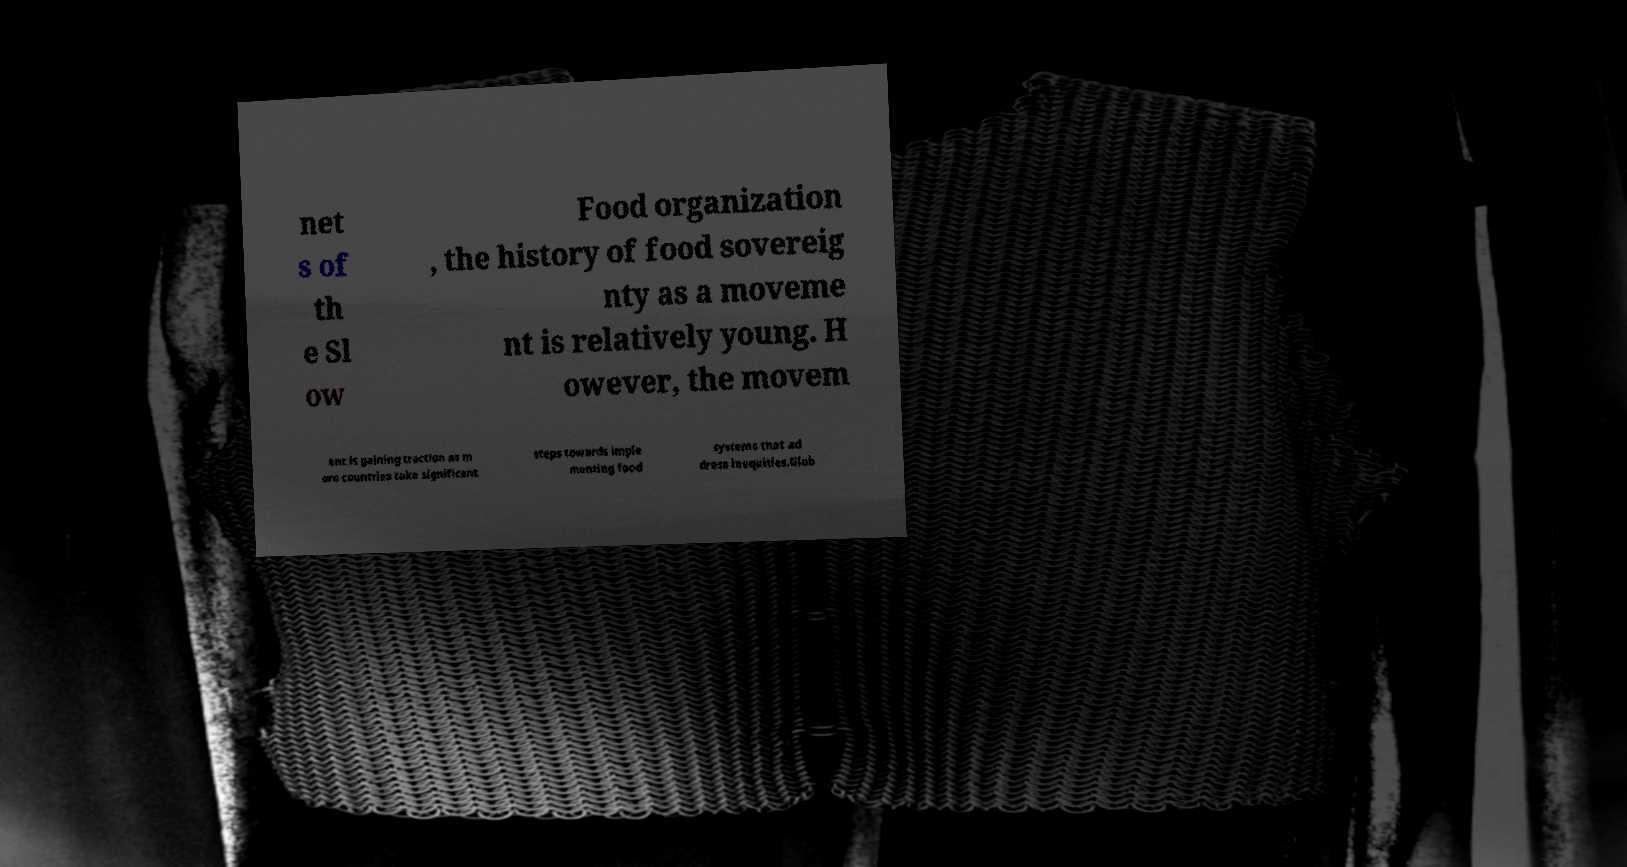For documentation purposes, I need the text within this image transcribed. Could you provide that? net s of th e Sl ow Food organization , the history of food sovereig nty as a moveme nt is relatively young. H owever, the movem ent is gaining traction as m ore countries take significant steps towards imple menting food systems that ad dress inequities.Glob 